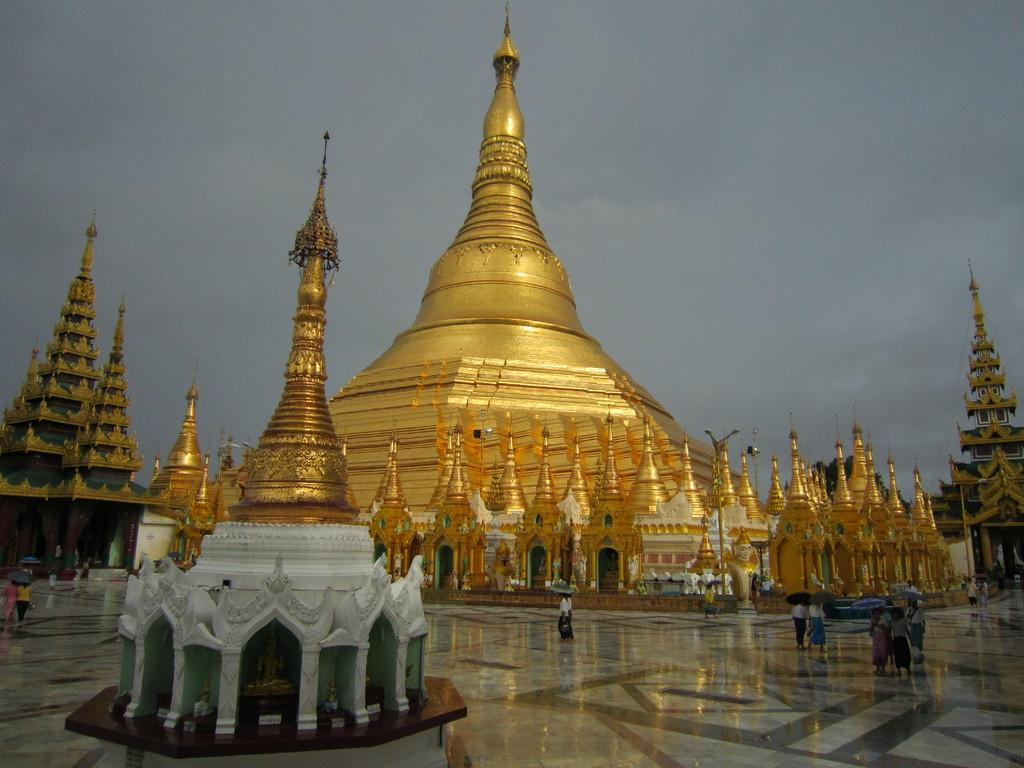What type of buildings can be seen in the image? There are temples in the image. Are there any people present in the image? Yes, there are people in the image. What are some people doing in the image? Some people are holding umbrellas. What is visible at the bottom of the image? There is a floor visible at the bottom of the image. What is visible at the top of the image? The sky is visible at the top of the image. What type of lead can be seen in the image? There is no lead present in the image. What color is the kitty in the image? There is no kitty present in the image. 